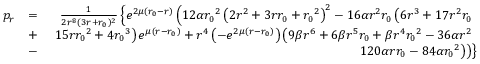<formula> <loc_0><loc_0><loc_500><loc_500>\begin{array} { r l r } { p _ { r } } & { = } & { \frac { 1 } { 2 r ^ { 8 } ( 3 r + { r _ { 0 } } ) ^ { 2 } } \left \{ e ^ { 2 \mu ( { r _ { 0 } } - r ) } \left ( 1 2 \alpha { r _ { 0 } } ^ { 2 } \left ( 2 r ^ { 2 } + 3 r { r _ { 0 } } + { r _ { 0 } } ^ { 2 } \right ) ^ { 2 } - 1 6 \alpha r ^ { 2 } { r _ { 0 } } \left ( 6 r ^ { 3 } + 1 7 r ^ { 2 } { r _ { 0 } } } \\ & { + } & { 1 5 r { r _ { 0 } } ^ { 2 } + 4 { r _ { 0 } } ^ { 3 } \right ) e ^ { \mu ( r - { r _ { 0 } } ) } + r ^ { 4 } \left ( - e ^ { 2 \mu ( r - { r _ { 0 } } ) } \right ) \left ( 9 \beta r ^ { 6 } + 6 \beta r ^ { 5 } { r _ { 0 } } + \beta r ^ { 4 } { r _ { 0 } } ^ { 2 } - 3 6 \alpha r ^ { 2 } } \\ & { - } & { 1 2 0 \alpha r { r _ { 0 } } - 8 4 \alpha { r _ { 0 } } ^ { 2 } \right ) \right ) \right \} } \end{array}</formula> 